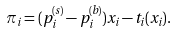<formula> <loc_0><loc_0><loc_500><loc_500>\pi _ { i } = ( p _ { i } ^ { ( s ) } - p _ { i } ^ { ( b ) } ) x _ { i } - t _ { i } ( x _ { i } ) .</formula> 